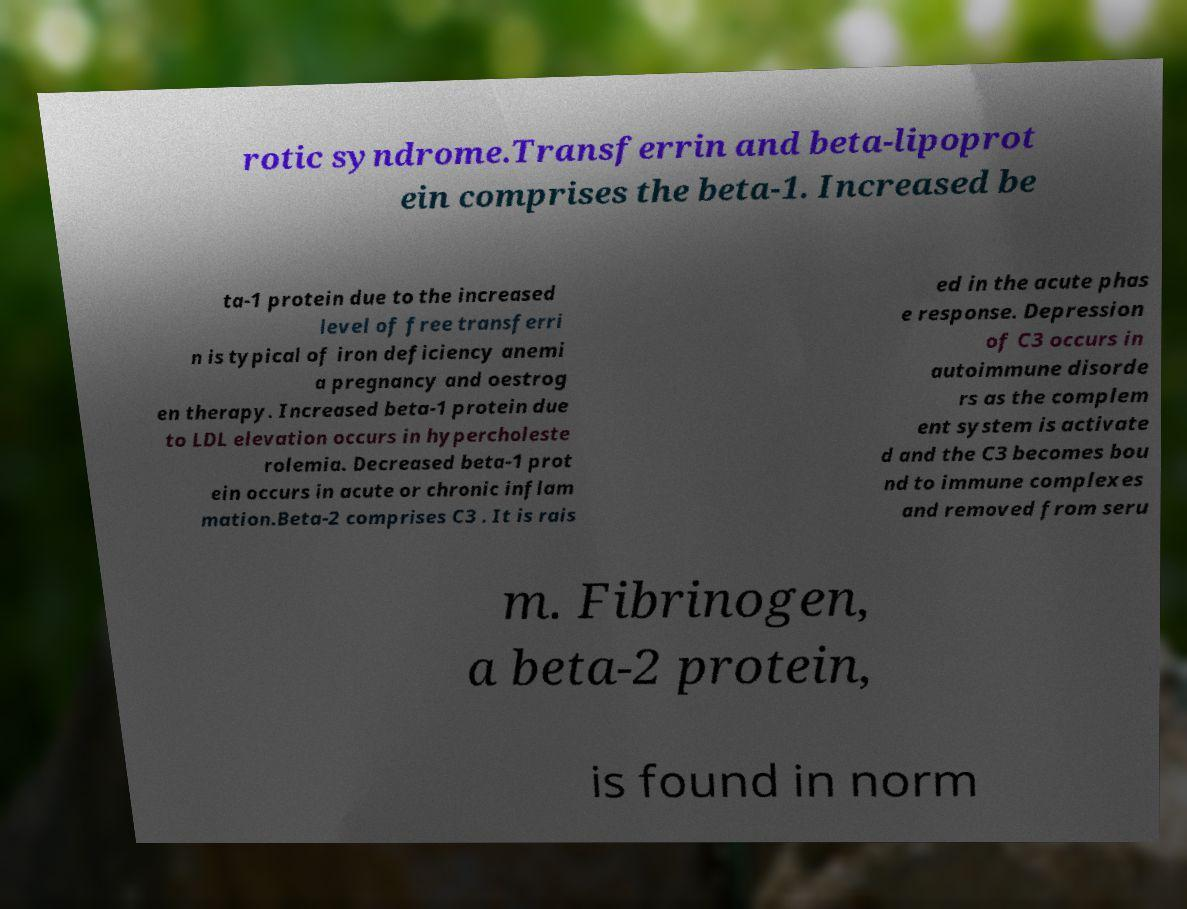Please read and relay the text visible in this image. What does it say? rotic syndrome.Transferrin and beta-lipoprot ein comprises the beta-1. Increased be ta-1 protein due to the increased level of free transferri n is typical of iron deficiency anemi a pregnancy and oestrog en therapy. Increased beta-1 protein due to LDL elevation occurs in hypercholeste rolemia. Decreased beta-1 prot ein occurs in acute or chronic inflam mation.Beta-2 comprises C3 . It is rais ed in the acute phas e response. Depression of C3 occurs in autoimmune disorde rs as the complem ent system is activate d and the C3 becomes bou nd to immune complexes and removed from seru m. Fibrinogen, a beta-2 protein, is found in norm 